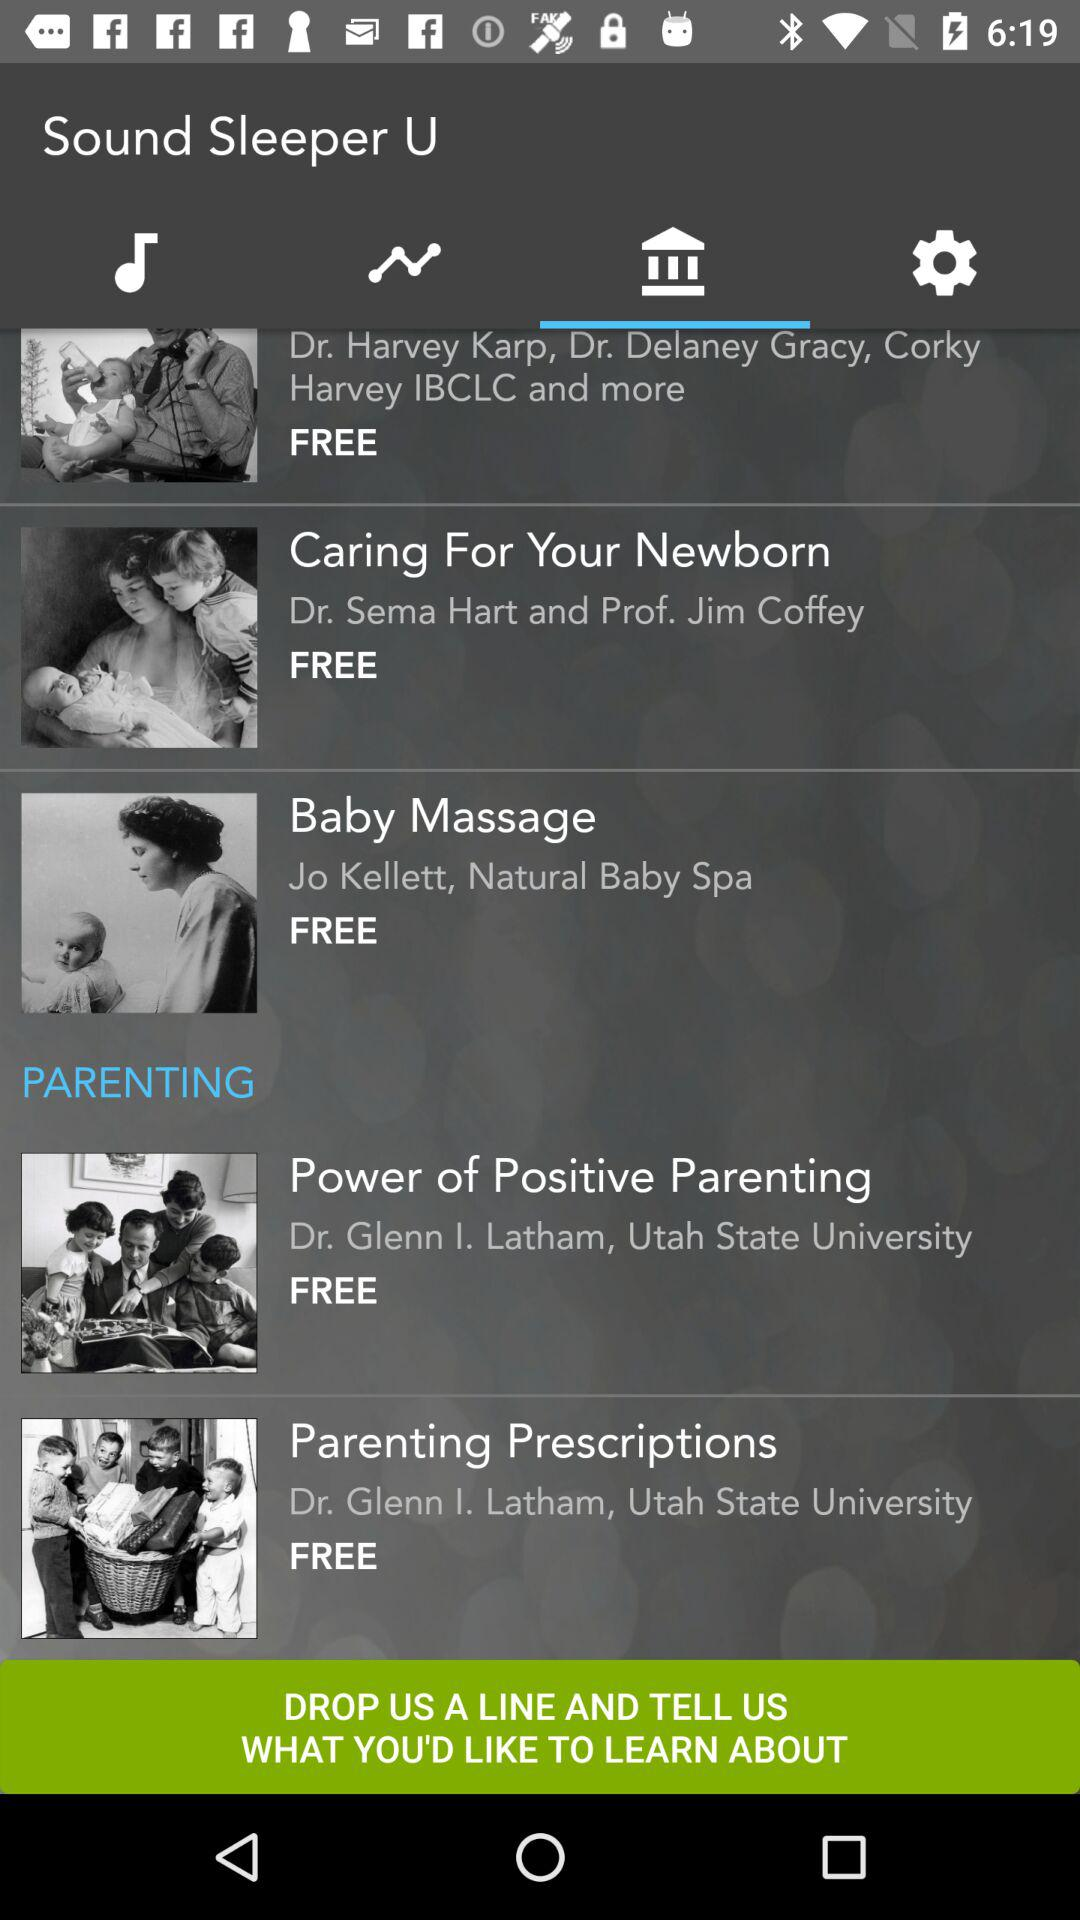How many items in the parenting section have Dr. Glenn I. Latham as a speaker?
Answer the question using a single word or phrase. 2 